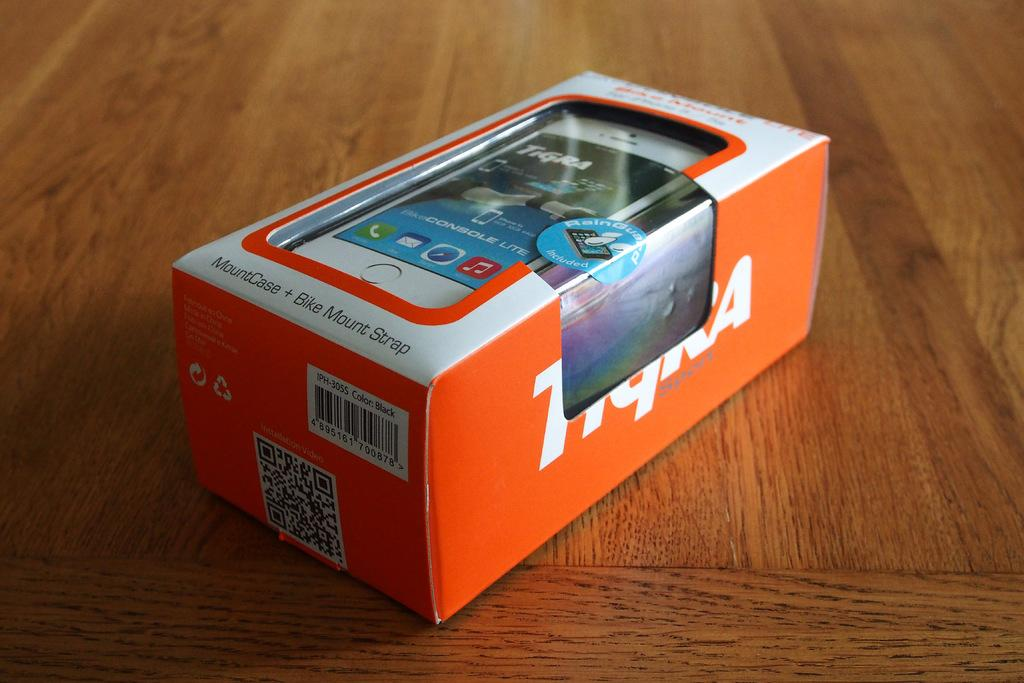<image>
Share a concise interpretation of the image provided. An orange and white box contains a mountcase and bike mount strap. 